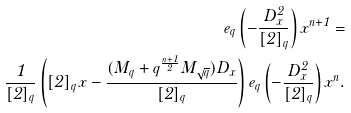<formula> <loc_0><loc_0><loc_500><loc_500>e _ { q } \left ( - \frac { D ^ { 2 } _ { x } } { [ 2 ] _ { q } } \right ) x ^ { n + 1 } = \\ \frac { 1 } { [ 2 ] _ { q } } \left ( [ 2 ] _ { q } \, x - \frac { ( M _ { q } + q ^ { \frac { n + 1 } { 2 } } M _ { \sqrt { q } } ) D _ { x } } { [ 2 ] _ { q } } \right ) e _ { q } \left ( - \frac { D ^ { 2 } _ { x } } { [ 2 ] _ { q } } \right ) x ^ { n } .</formula> 